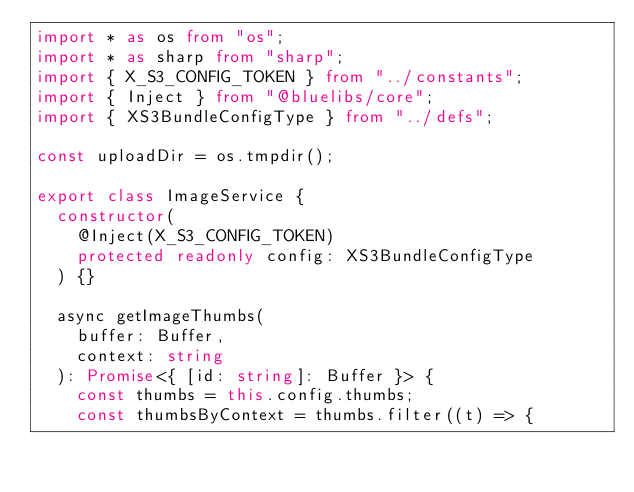<code> <loc_0><loc_0><loc_500><loc_500><_TypeScript_>import * as os from "os";
import * as sharp from "sharp";
import { X_S3_CONFIG_TOKEN } from "../constants";
import { Inject } from "@bluelibs/core";
import { XS3BundleConfigType } from "../defs";

const uploadDir = os.tmpdir();

export class ImageService {
  constructor(
    @Inject(X_S3_CONFIG_TOKEN)
    protected readonly config: XS3BundleConfigType
  ) {}

  async getImageThumbs(
    buffer: Buffer,
    context: string
  ): Promise<{ [id: string]: Buffer }> {
    const thumbs = this.config.thumbs;
    const thumbsByContext = thumbs.filter((t) => {</code> 